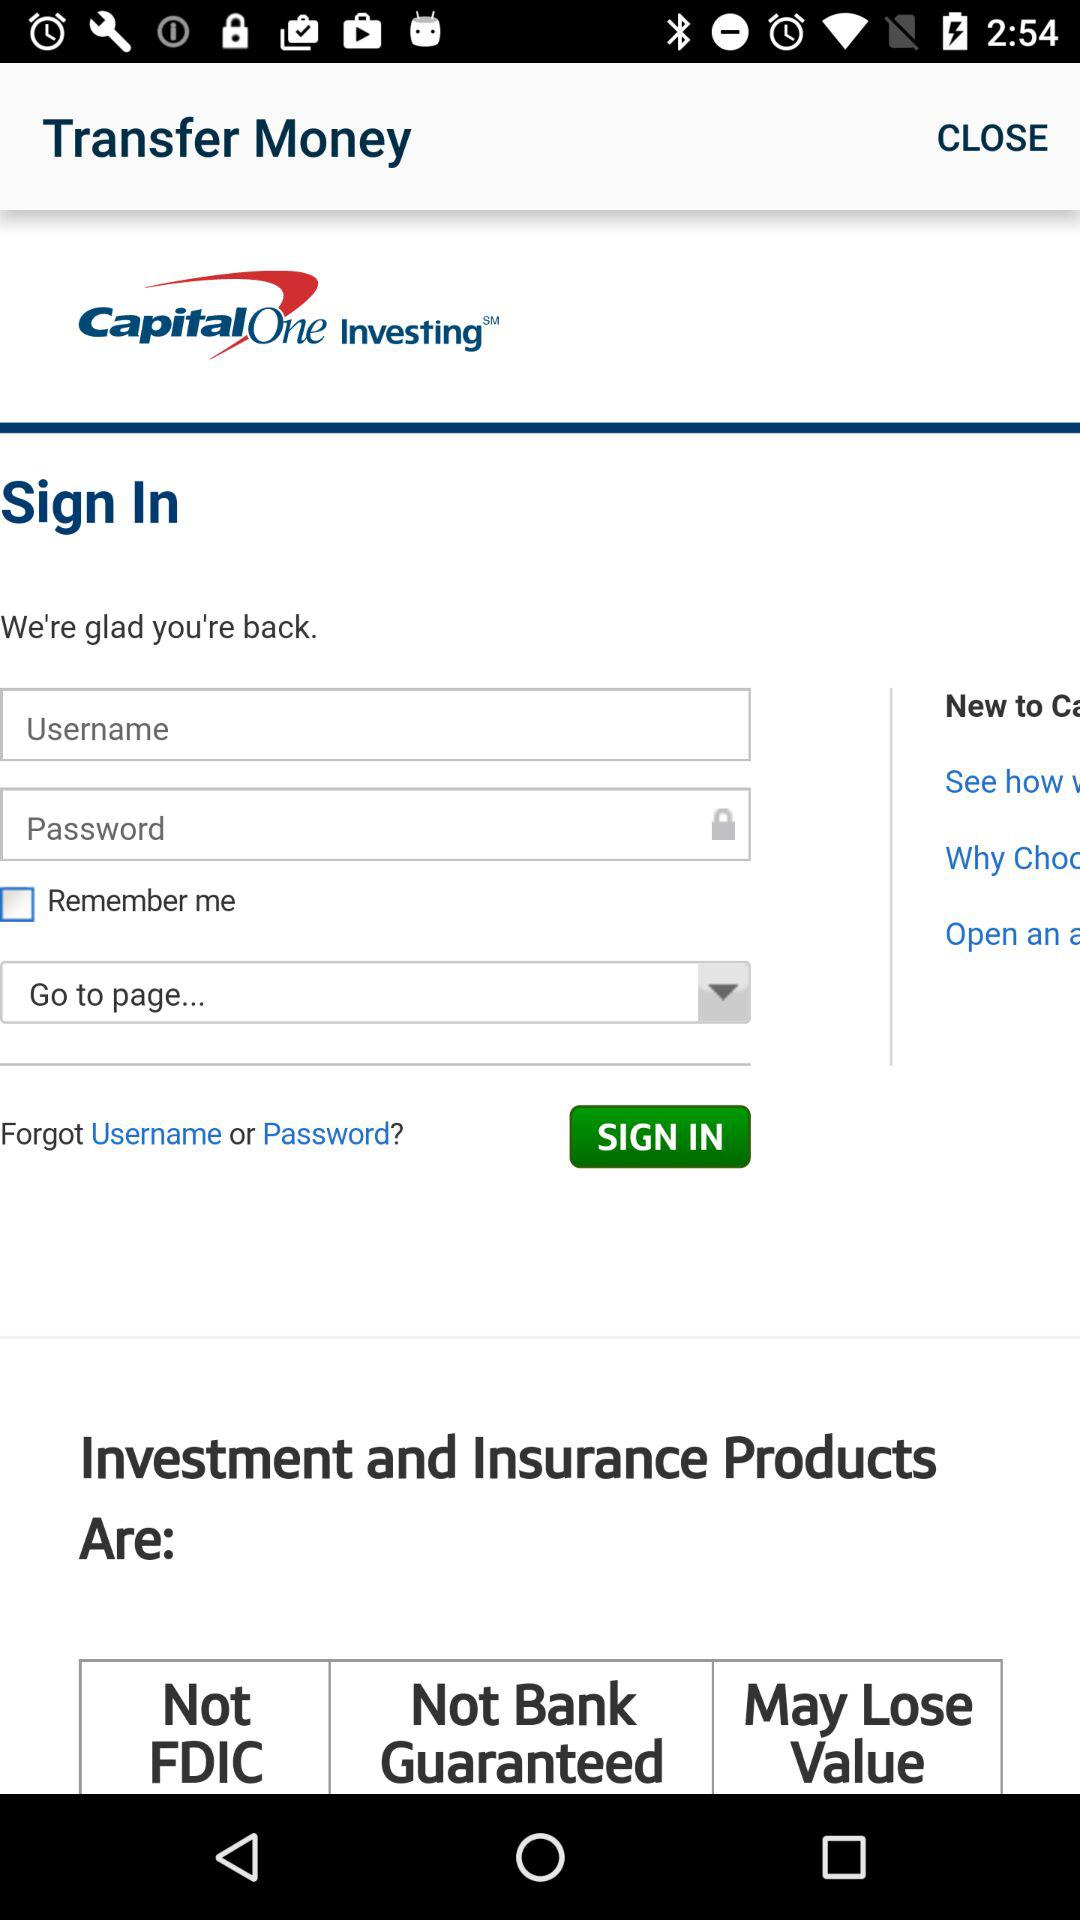Can we reset username and password?
When the provided information is insufficient, respond with <no answer>. <no answer> 